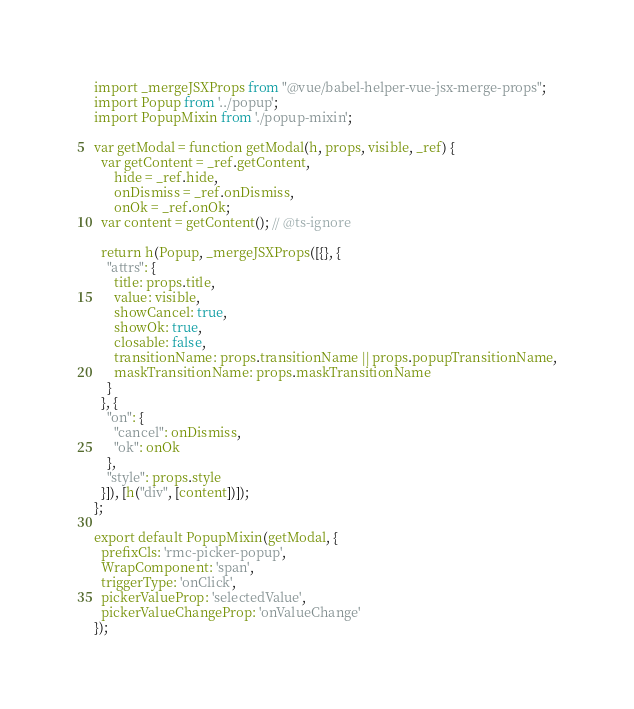Convert code to text. <code><loc_0><loc_0><loc_500><loc_500><_JavaScript_>import _mergeJSXProps from "@vue/babel-helper-vue-jsx-merge-props";
import Popup from '../popup';
import PopupMixin from './popup-mixin';

var getModal = function getModal(h, props, visible, _ref) {
  var getContent = _ref.getContent,
      hide = _ref.hide,
      onDismiss = _ref.onDismiss,
      onOk = _ref.onOk;
  var content = getContent(); // @ts-ignore

  return h(Popup, _mergeJSXProps([{}, {
    "attrs": {
      title: props.title,
      value: visible,
      showCancel: true,
      showOk: true,
      closable: false,
      transitionName: props.transitionName || props.popupTransitionName,
      maskTransitionName: props.maskTransitionName
    }
  }, {
    "on": {
      "cancel": onDismiss,
      "ok": onOk
    },
    "style": props.style
  }]), [h("div", [content])]);
};

export default PopupMixin(getModal, {
  prefixCls: 'rmc-picker-popup',
  WrapComponent: 'span',
  triggerType: 'onClick',
  pickerValueProp: 'selectedValue',
  pickerValueChangeProp: 'onValueChange'
});</code> 